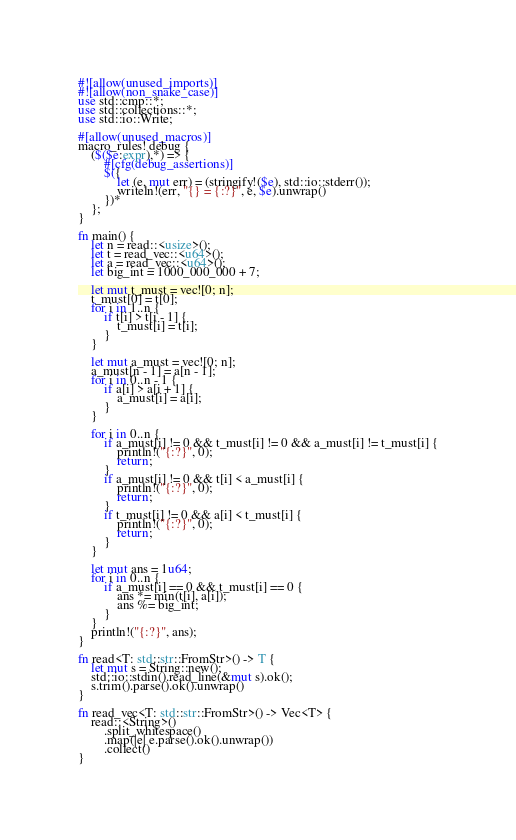<code> <loc_0><loc_0><loc_500><loc_500><_Rust_>#![allow(unused_imports)]
#![allow(non_snake_case)]
use std::cmp::*;
use std::collections::*;
use std::io::Write;

#[allow(unused_macros)]
macro_rules! debug {
    ($($e:expr),*) => {
        #[cfg(debug_assertions)]
        $({
            let (e, mut err) = (stringify!($e), std::io::stderr());
            writeln!(err, "{} = {:?}", e, $e).unwrap()
        })*
    };
}

fn main() {
    let n = read::<usize>();
    let t = read_vec::<u64>();
    let a = read_vec::<u64>();
    let big_int = 1000_000_000 + 7;

    let mut t_must = vec![0; n];
    t_must[0] = t[0];
    for i in 1..n {
        if t[i] > t[i - 1] {
            t_must[i] = t[i];
        }
    }

    let mut a_must = vec![0; n];
    a_must[n - 1] = a[n - 1];
    for i in 0..n - 1 {
        if a[i] > a[i + 1] {
            a_must[i] = a[i];
        }
    }

    for i in 0..n {
        if a_must[i] != 0 && t_must[i] != 0 && a_must[i] != t_must[i] {
            println!("{:?}", 0);
            return;
        }
        if a_must[i] != 0 && t[i] < a_must[i] {
            println!("{:?}", 0);
            return;
        }
        if t_must[i] != 0 && a[i] < t_must[i] {
            println!("{:?}", 0);
            return;
        }
    }

    let mut ans = 1u64;
    for i in 0..n {
        if a_must[i] == 0 && t_must[i] == 0 {
            ans *= min(t[i], a[i]);
            ans %= big_int;
        }
    }
    println!("{:?}", ans);
}

fn read<T: std::str::FromStr>() -> T {
    let mut s = String::new();
    std::io::stdin().read_line(&mut s).ok();
    s.trim().parse().ok().unwrap()
}

fn read_vec<T: std::str::FromStr>() -> Vec<T> {
    read::<String>()
        .split_whitespace()
        .map(|e| e.parse().ok().unwrap())
        .collect()
}
</code> 